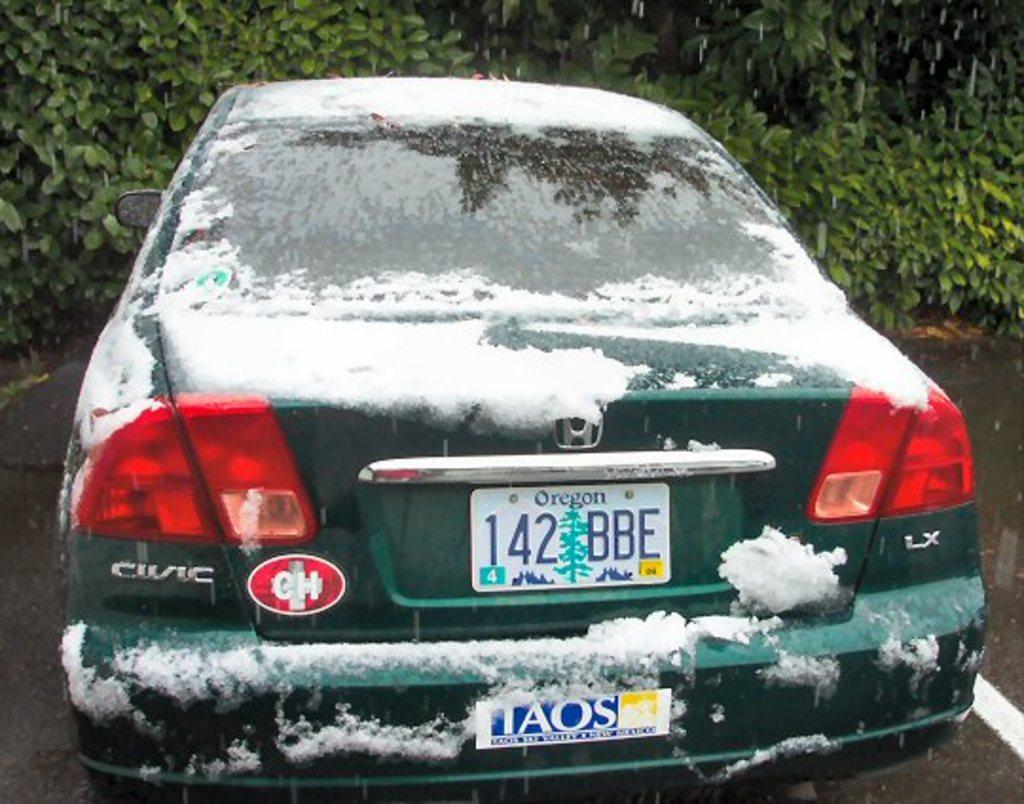<image>
Summarize the visual content of the image. A snow covered Honda Civic that is parked, has a bumper sticker with the letters TAOS on it. 